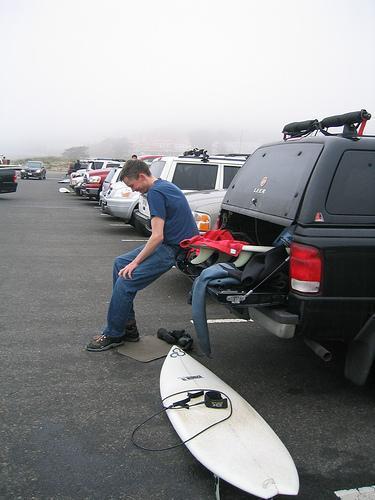How many trucks are there?
Give a very brief answer. 2. How many cars are there?
Give a very brief answer. 2. How many giraffes are not reaching towards the woman?
Give a very brief answer. 0. 